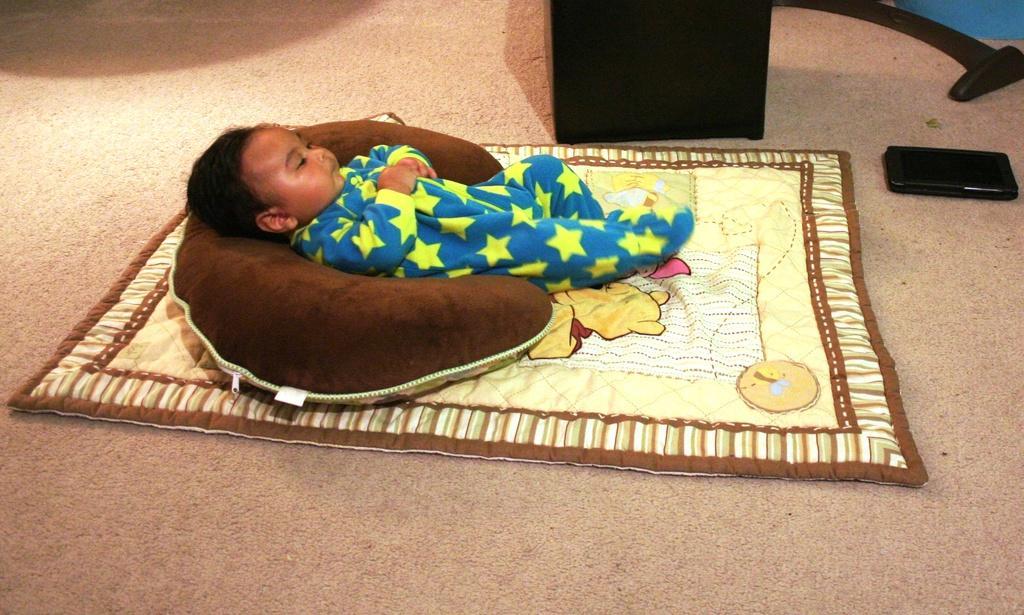How would you summarize this image in a sentence or two? In this image I can see a baby lying on the bed. On the right side, I can see a device on the floor. 